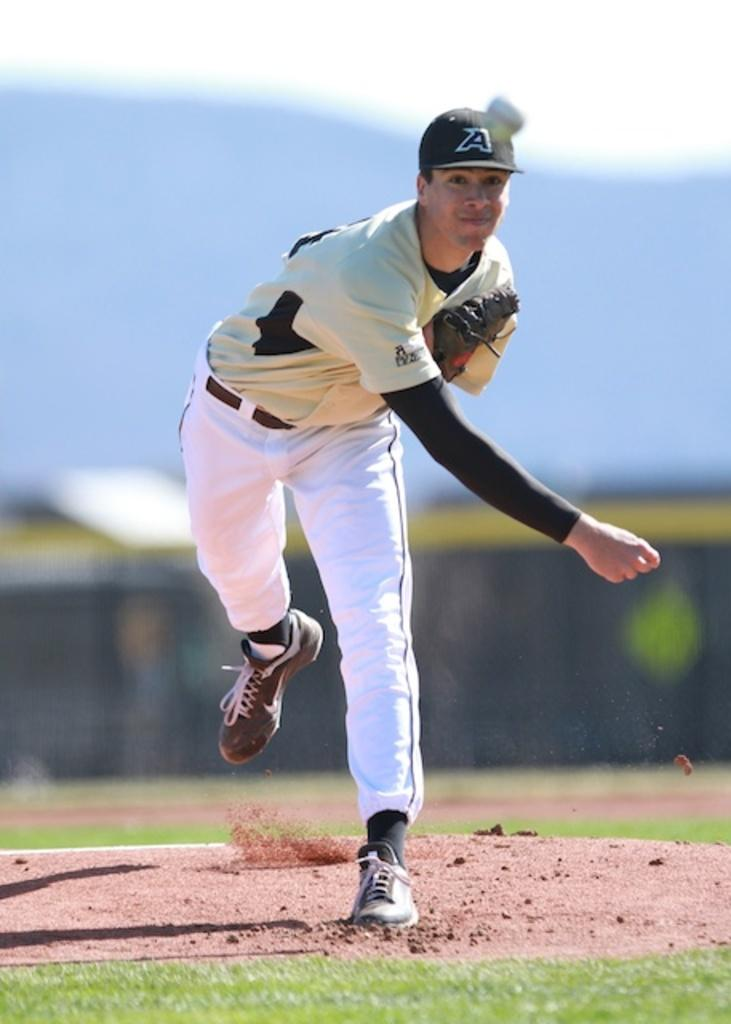<image>
Relay a brief, clear account of the picture shown. a baseball pitcher on the mound from the A team 